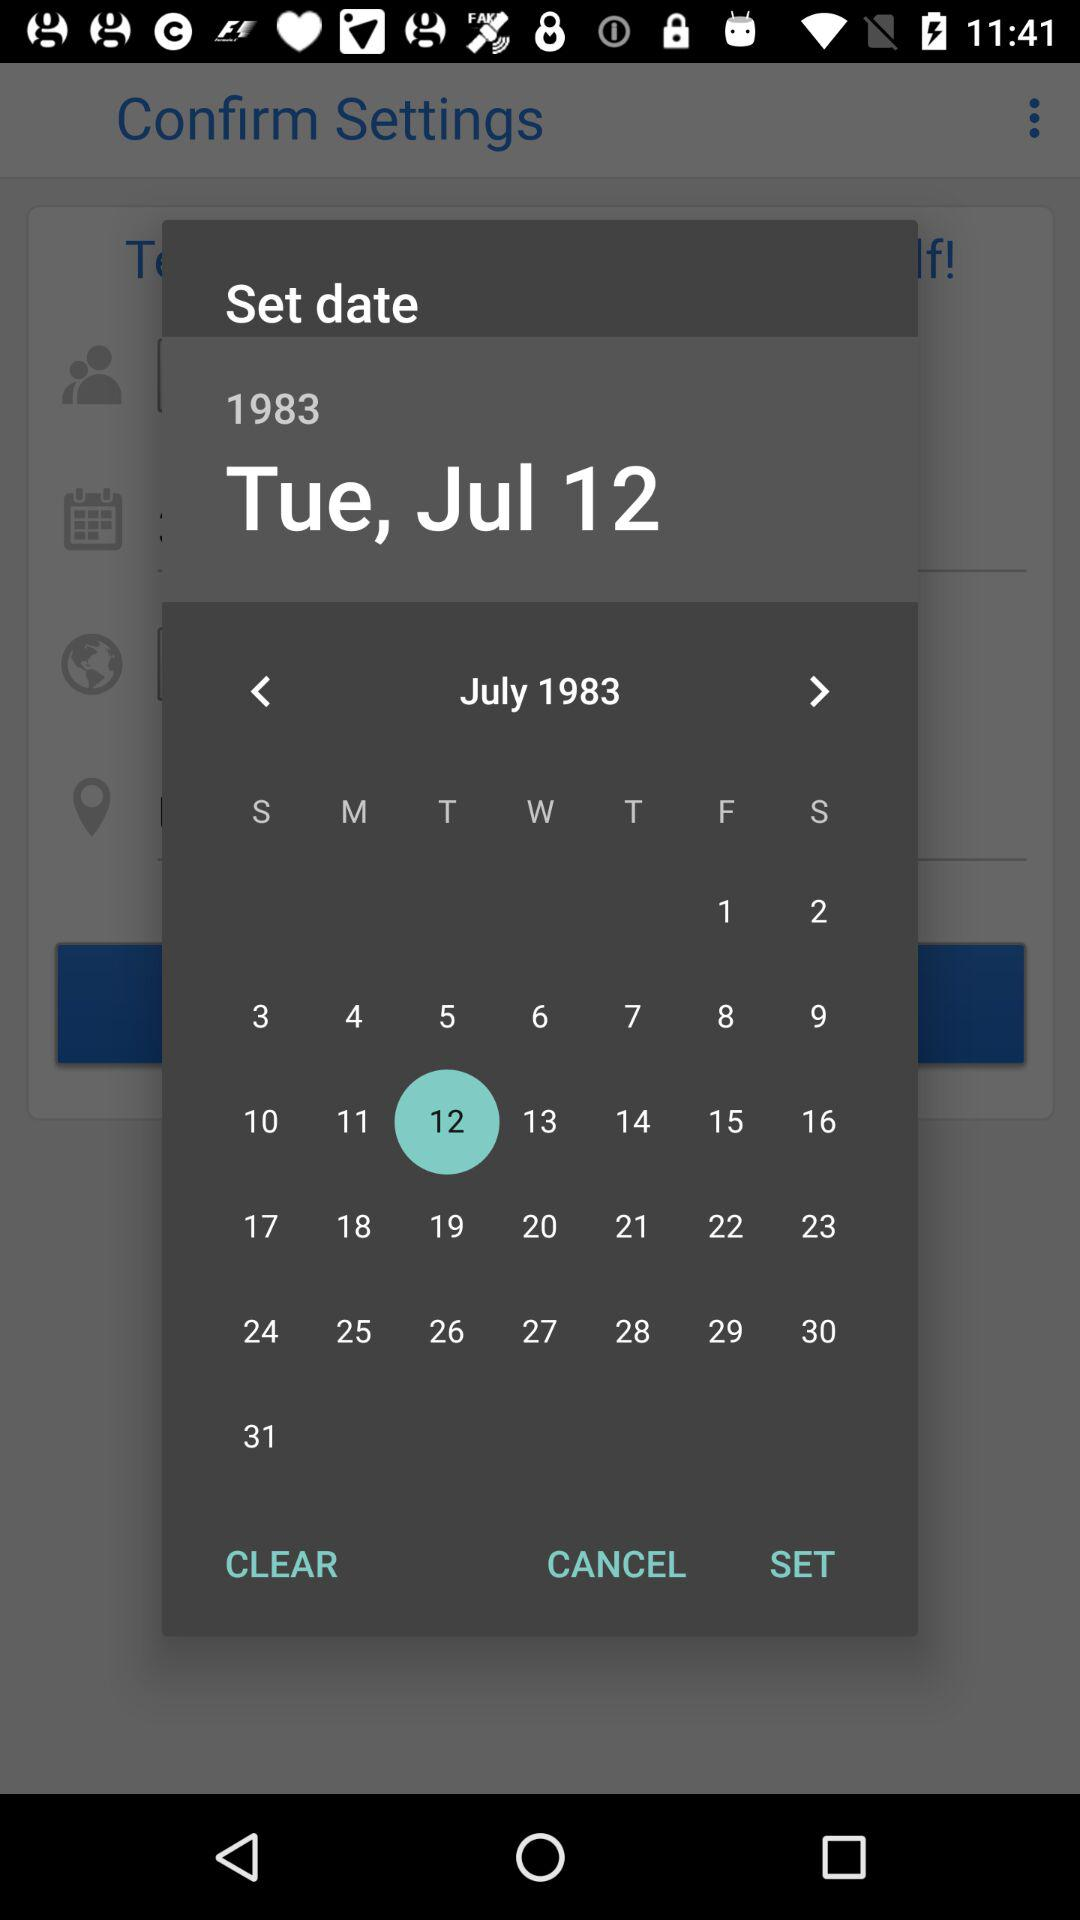Which date is selected? The selected date is Tuesday, July 12, 1983. 